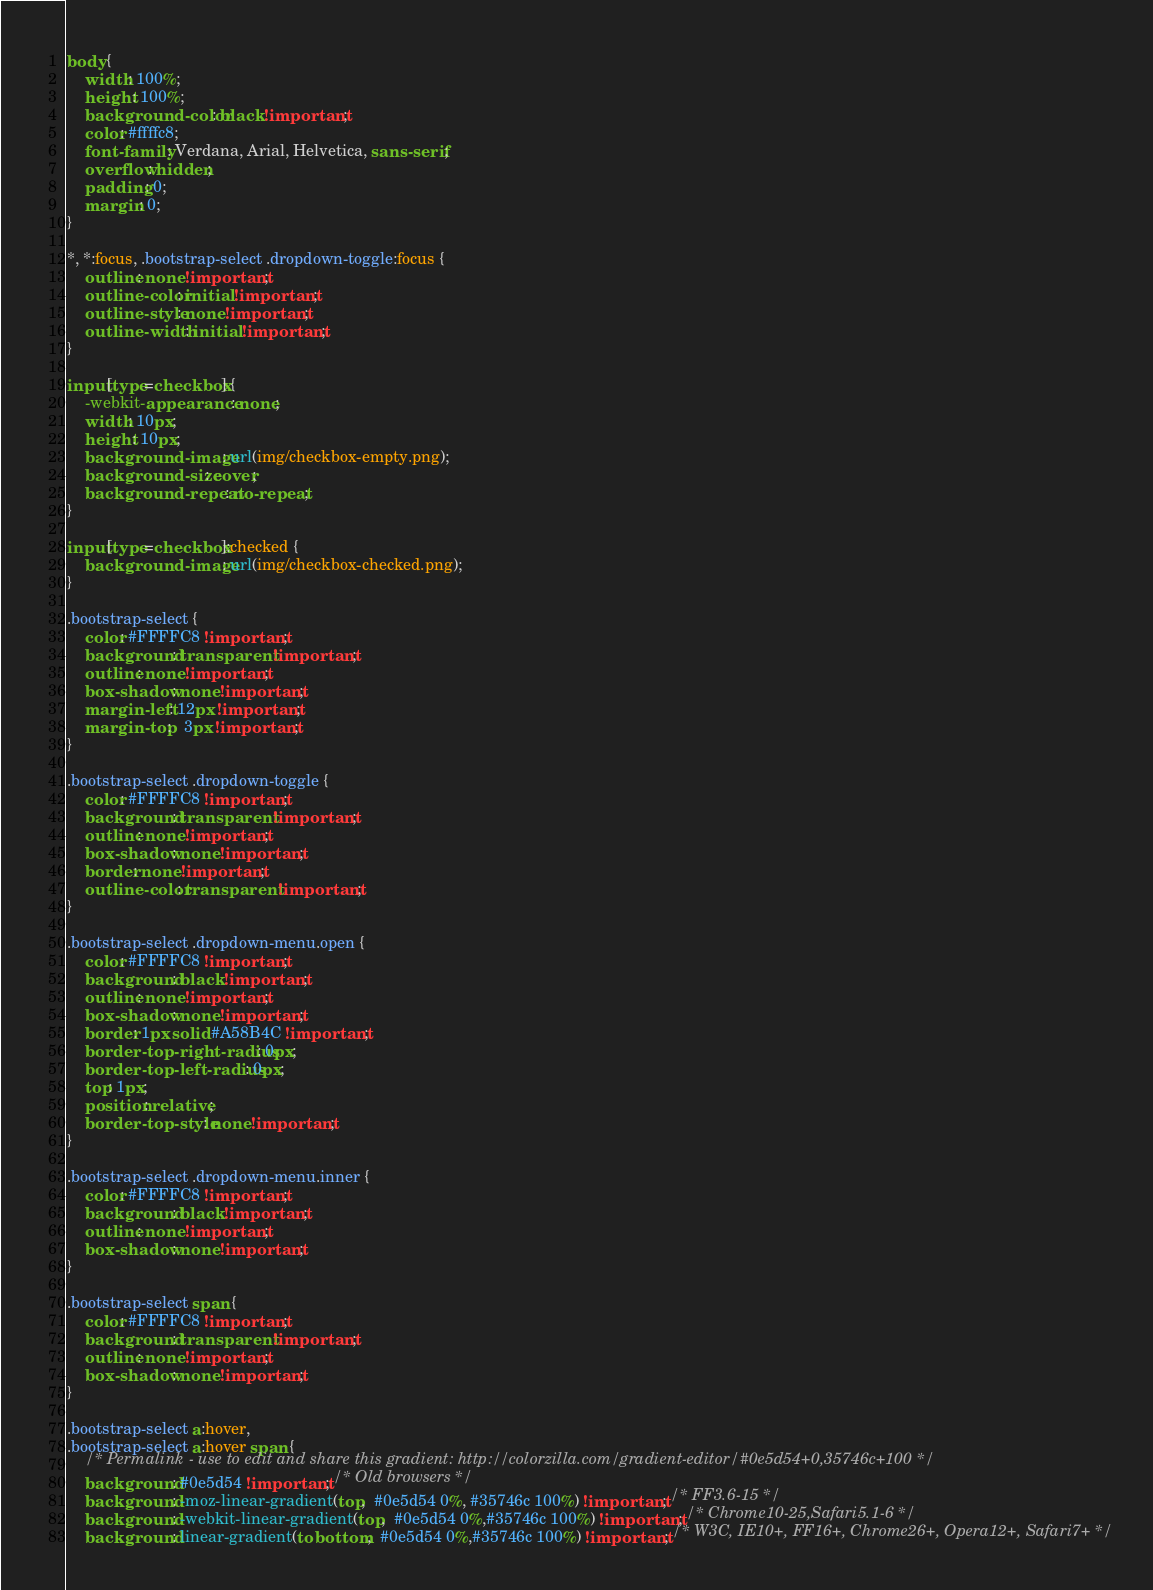Convert code to text. <code><loc_0><loc_0><loc_500><loc_500><_CSS_>body {
	width: 100%;
	height: 100%;
	background-color: black !important;
	color: #ffffc8;
	font-family: Verdana, Arial, Helvetica, sans-serif;
	overflow: hidden;
	padding: 0;
	margin: 0;
}

*, *:focus, .bootstrap-select .dropdown-toggle:focus {
	outline: none !important;
	outline-color: initial !important;
	outline-style: none !important;
	outline-width: initial !important;
}

input[type=checkbox] {
	-webkit-appearance: none;
	width: 10px;
	height: 10px;
	background-image: url(img/checkbox-empty.png);
	background-size: cover;
	background-repeat: no-repeat;
}

input[type=checkbox]:checked {
	background-image: url(img/checkbox-checked.png);
}

.bootstrap-select {
	color: #FFFFC8 !important;
	background: transparent !important;
	outline: none !important;
	box-shadow: none !important;
	margin-left: 12px !important;
	margin-top:   3px !important;
}

.bootstrap-select .dropdown-toggle {
	color: #FFFFC8 !important;
	background: transparent !important;
	outline: none !important;
	box-shadow: none !important;
	border: none !important;
	outline-color: transparent !important;
}

.bootstrap-select .dropdown-menu.open {
	color: #FFFFC8 !important;
	background: black !important;
	outline: none !important;
	box-shadow: none !important;
	border: 1px solid #A58B4C !important;
	border-top-right-radius: 0px;
	border-top-left-radius: 0px;
	top: 1px;
	position: relative;
	border-top-style: none !important;
}

.bootstrap-select .dropdown-menu.inner {
	color: #FFFFC8 !important;
	background: black !important;
	outline: none !important;
	box-shadow: none !important;
}

.bootstrap-select span {
	color: #FFFFC8 !important;
	background: transparent !important;
	outline: none !important;
	box-shadow: none !important;
}

.bootstrap-select a:hover,
.bootstrap-select a:hover span {
	/* Permalink - use to edit and share this gradient: http://colorzilla.com/gradient-editor/#0e5d54+0,35746c+100 */
	background: #0e5d54 !important; /* Old browsers */
	background: -moz-linear-gradient(top,  #0e5d54 0%, #35746c 100%) !important; /* FF3.6-15 */
	background: -webkit-linear-gradient(top,  #0e5d54 0%,#35746c 100%) !important; /* Chrome10-25,Safari5.1-6 */
	background: linear-gradient(to bottom,  #0e5d54 0%,#35746c 100%) !important; /* W3C, IE10+, FF16+, Chrome26+, Opera12+, Safari7+ */</code> 